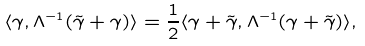<formula> <loc_0><loc_0><loc_500><loc_500>\langle \gamma , \Lambda ^ { - 1 } ( \tilde { \gamma } + \gamma ) \rangle = \frac { 1 } { 2 } \langle \gamma + \tilde { \gamma } , { \Lambda } ^ { - 1 } ( \gamma + \tilde { \gamma } ) \rangle ,</formula> 